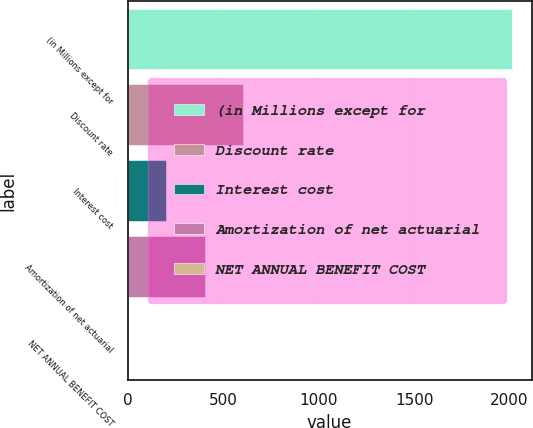<chart> <loc_0><loc_0><loc_500><loc_500><bar_chart><fcel>(in Millions except for<fcel>Discount rate<fcel>Interest cost<fcel>Amortization of net actuarial<fcel>NET ANNUAL BENEFIT COST<nl><fcel>2015<fcel>604.71<fcel>201.77<fcel>403.24<fcel>0.3<nl></chart> 